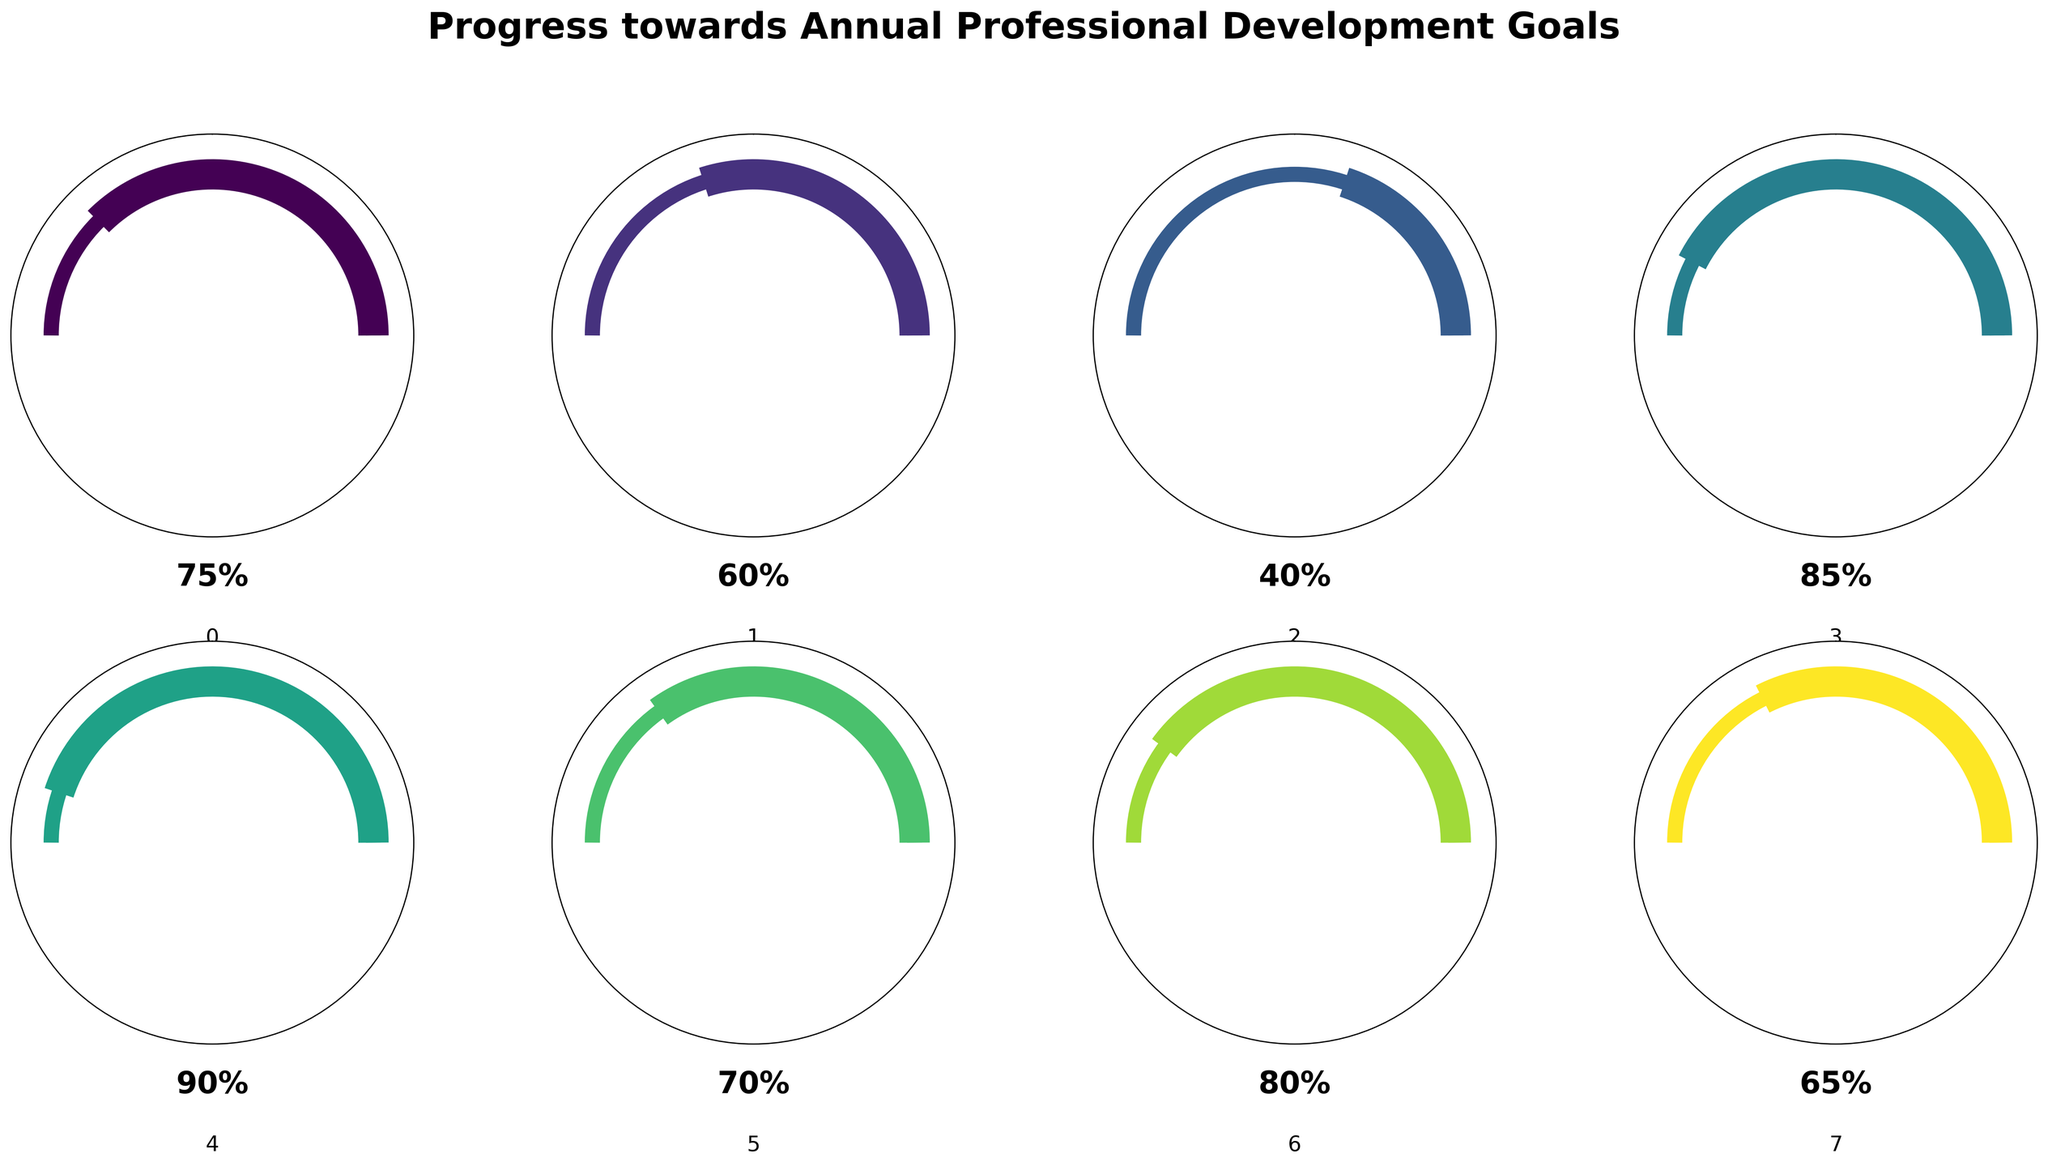What's the goal with the highest progress percentage? Look for the gauge chart with the highest value indicated on it. The highest percentage value is 90%, corresponding to Mentoring Program Participation.
Answer: Mentoring Program Participation What's the average progress percentage of all goals? Sum all progress percentages: 75 + 60 + 40 + 85 + 90 + 70 + 80 + 65 = 565. Divide by the number of goals (8). The average progress percentage is 565 / 8 = 70.625.
Answer: 70.625 Which goal has the lowest progress percentage? Look for the gauge chart with the lowest value indicated on it. The lowest percentage value is 40%, corresponding to Industry Certification.
Answer: Industry Certification How much more progress has Assistive Technology Proficiency made compared to Professional Network Expansion? Subtract the progress percentage of Professional Network Expansion (65%) from that of Assistive Technology Proficiency (85%). The difference is 85 - 65 = 20.
Answer: 20 What is the total progress percentage for Leadership Training and Inclusive Workplace Initiatives combined? Add the progress percentages of Leadership Training (60%) and Inclusive Workplace Initiatives (70%). The sum is 60 + 70 = 130.
Answer: 130 Which goals have progress percentages above 75%? Identify all goals with progress percentages above 75%: Public Speaking Skills (75%), Assistive Technology Proficiency (85%), Mentoring Program Participation (90%), and Adaptive Learning Strategies (80%).
Answer: Public Speaking Skills, Assistive Technology Proficiency, Mentoring Program Participation, Adaptive Learning Strategies What is the difference in progress between Public Speaking Skills and Leadership Training? Subtract the progress percentage of Leadership Training (60%) from that of Public Speaking Skills (75%). The difference is 75 - 60 = 15.
Answer: 15 If the total progress percentage of all goals should sum to at least 600, how much more progress needs to be made in total? Sum all progress percentages and subtract the total from 600 to find the deficit. Current total is 565. The deficit is 600 - 565 = 35.
Answer: 35 Which goal is exactly halfway to completion (i.e., 50% progress)? Identify the gauge chart that indicates 50% progress. None of the goals have a percentage of 50%.
Answer: None Which goals fall in the range of 60-80% progress? Identify all goals with progress percentages between 60% and 80%: Public Speaking Skills (75%), Leadership Training (60%), Inclusive Workplace Initiatives (70%), and Adaptive Learning Strategies (80%).
Answer: Public Speaking Skills, Leadership Training, Inclusive Workplace Initiatives, Adaptive Learning Strategies 